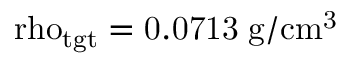Convert formula to latex. <formula><loc_0><loc_0><loc_500><loc_500>\ r h o _ { t g t } = 0 . 0 7 1 3 \, \mathrm { g / c m ^ { 3 } }</formula> 